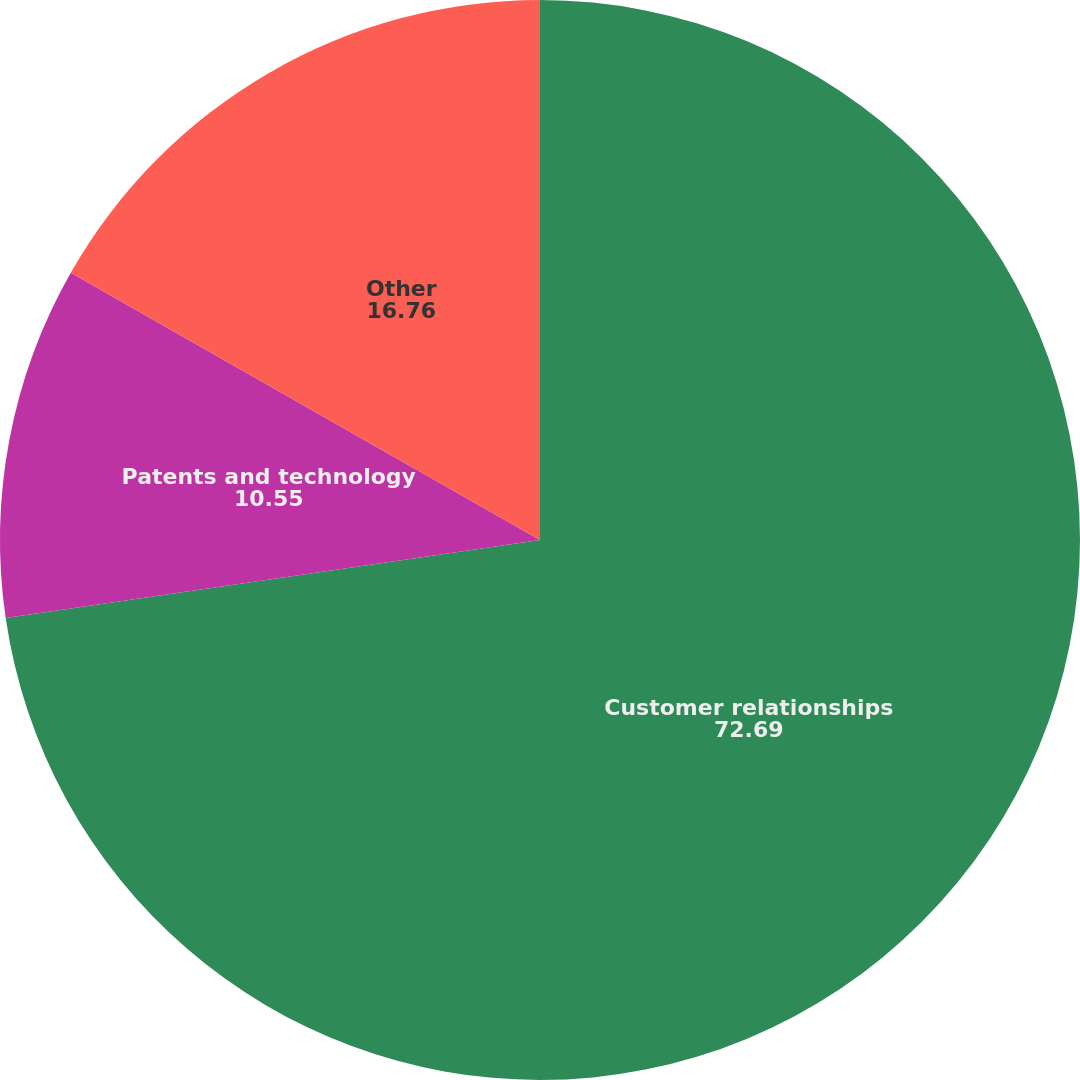Convert chart. <chart><loc_0><loc_0><loc_500><loc_500><pie_chart><fcel>Customer relationships<fcel>Patents and technology<fcel>Other<nl><fcel>72.69%<fcel>10.55%<fcel>16.76%<nl></chart> 